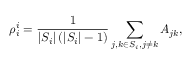Convert formula to latex. <formula><loc_0><loc_0><loc_500><loc_500>\rho _ { i } ^ { i } = \frac { 1 } { \left | S _ { i } \right | \left ( \left | S _ { i } \right | - 1 \right ) } \sum _ { j , k \in S _ { i } , j \neq k } A _ { j k } ,</formula> 